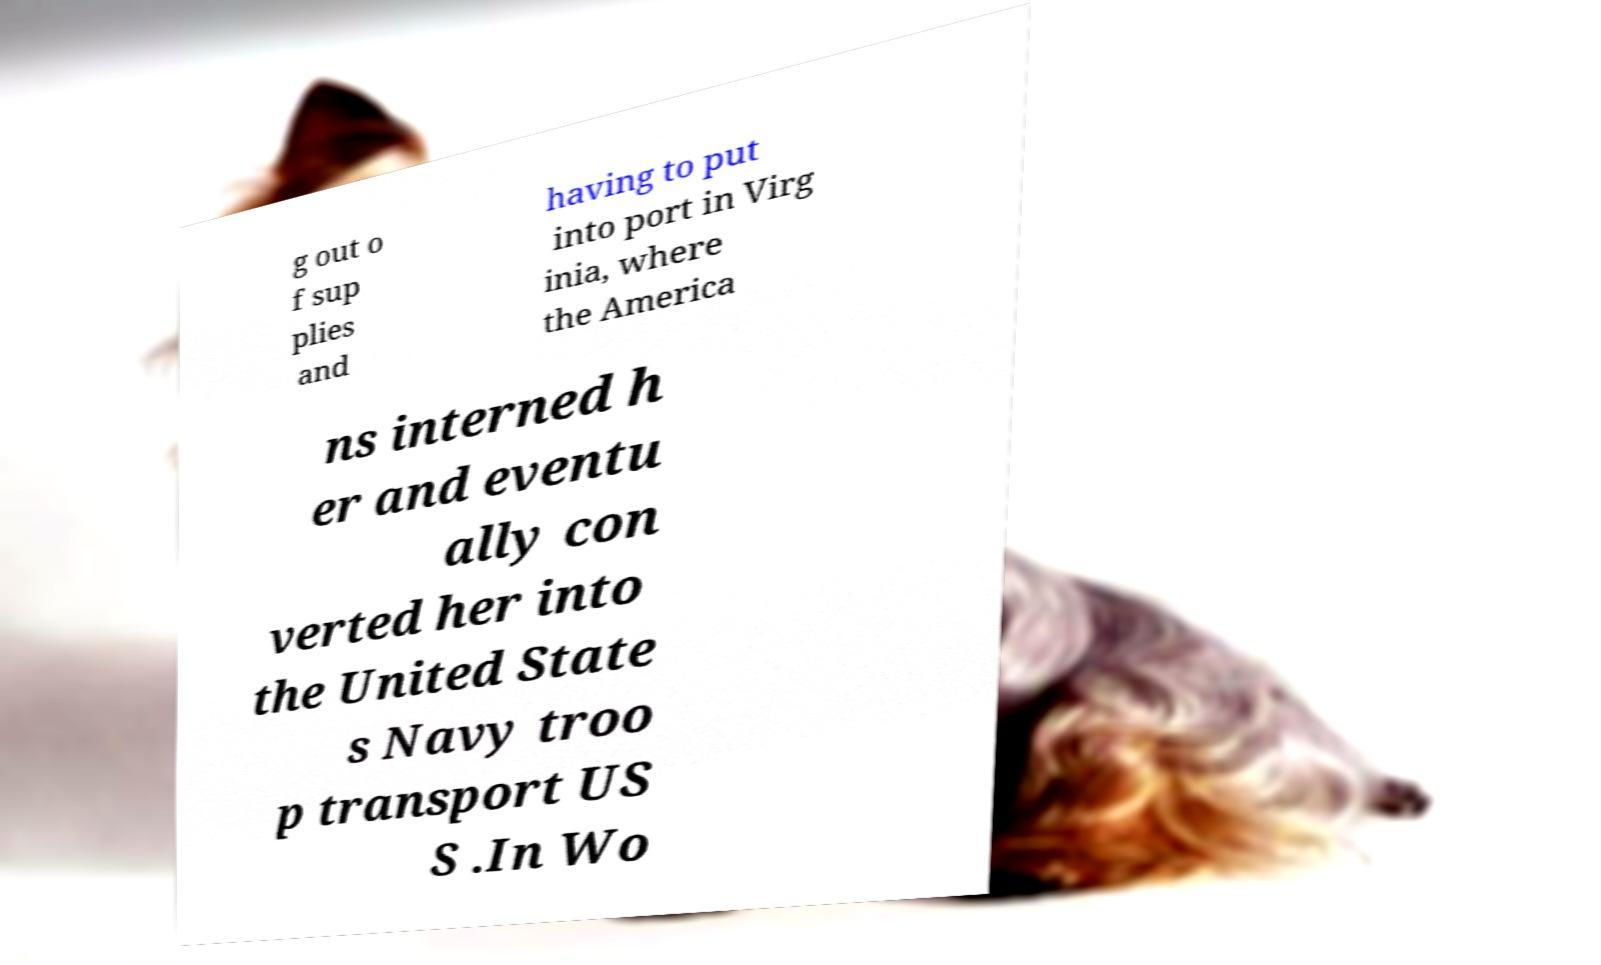Please identify and transcribe the text found in this image. g out o f sup plies and having to put into port in Virg inia, where the America ns interned h er and eventu ally con verted her into the United State s Navy troo p transport US S .In Wo 